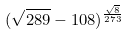Convert formula to latex. <formula><loc_0><loc_0><loc_500><loc_500>( \sqrt { 2 8 9 } - 1 0 8 ) ^ { \frac { \sqrt { 8 } } { 2 7 3 } }</formula> 